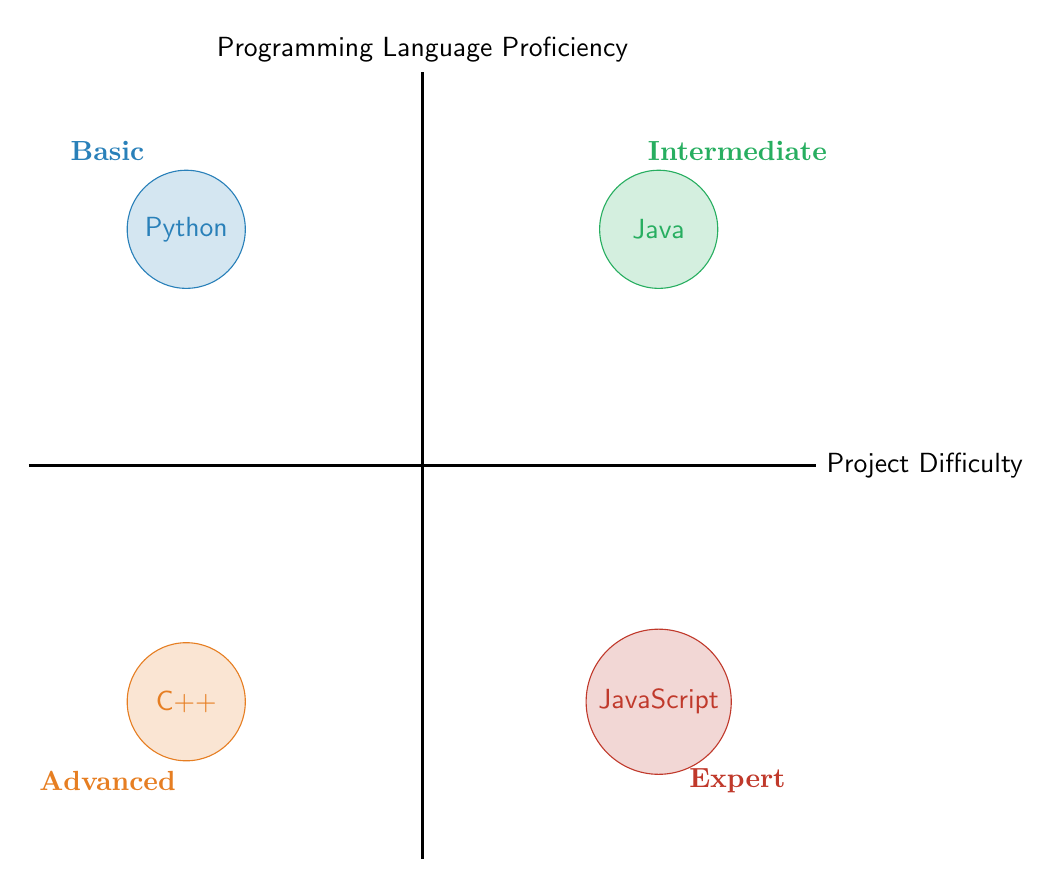What programming language is positioned in the 'Basic' section? The 'Basic' section is located in the upper left quadrant of the chart. The language in this section is clearly labeled as Python.
Answer: Python What is the project difficulty for Java? Java is located in the upper right quadrant of the chart, which corresponds to the 'Intermediate' project difficulty level.
Answer: Intermediate Which programming language corresponds to 'Advanced' difficulty? The 'Advanced' difficulty level is found in the lower left quadrant. The programming language in this section is clearly labeled as C++.
Answer: C++ How many programming languages are represented in the chart? The chart includes four distinct programming languages, as indicated by the four labeled circles within the diagram.
Answer: Four Which language has the highest proficiency level? Looking at the lower right quadrant, which represents the 'Expert' level of proficiency, JavaScript is the language that is positioned here, indicating it has the highest proficiency level.
Answer: JavaScript What is the relationship between Python and C++ in terms of project difficulty? Python is positioned in the 'Basic' section while C++ is located in the 'Advanced' section, implying that as project difficulty increases, proficiency in C++ is required over Python.
Answer: C++ is more difficult than Python Which programming language has the lowest difficulty level? The 'Basic' section, where Python is placed, represents the lowest project difficulty level among the languages shown on the chart.
Answer: Python Can you name the quadrant representing 'Expert' proficiency? The 'Expert' proficiency level is located in the lower right quadrant of the chart, clearly labeled as such, indicating the highest level of difficulty in the diagram.
Answer: Lower right quadrant What color represents Intermediate proficiency? The 'Intermediate' proficiency level is depicted using green color in the chart, which visually distinguishes it from the other proficiency levels.
Answer: Green 